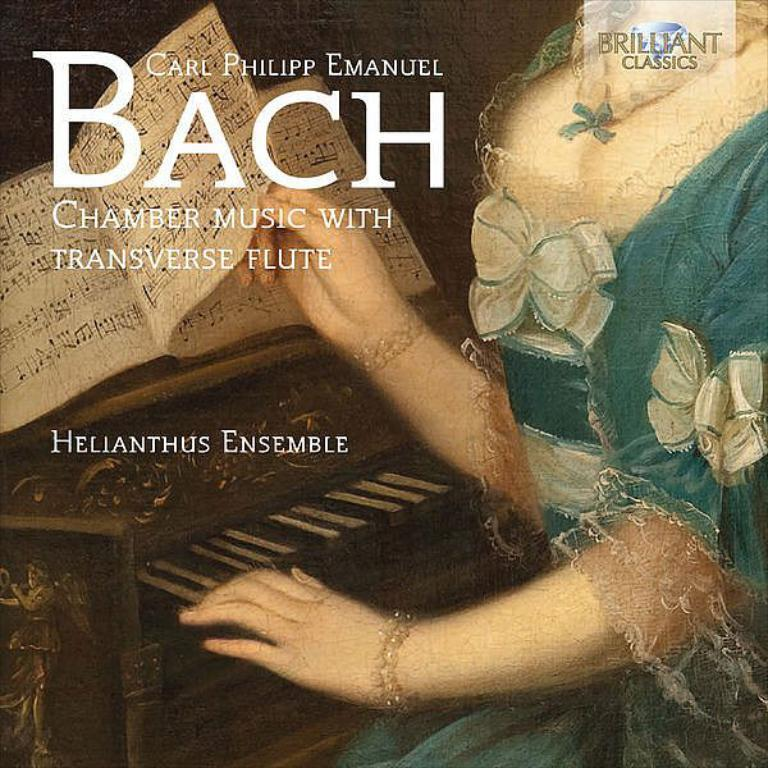What can be seen in the image? There is a person in the image. Can you describe the person's appearance? The person's face is not visible in the image. What is the person holding? The person is holding a page. Are there any objects or instruments in the image? Yes, there is a piano in the bottom left of the image. What type of twig is the person using to write on the page? There is no twig present in the image; the person is holding a page without any writing instrument. What stage of development is the person in? The image does not provide any information about the person's developmental stage. 